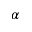<formula> <loc_0><loc_0><loc_500><loc_500>\alpha</formula> 